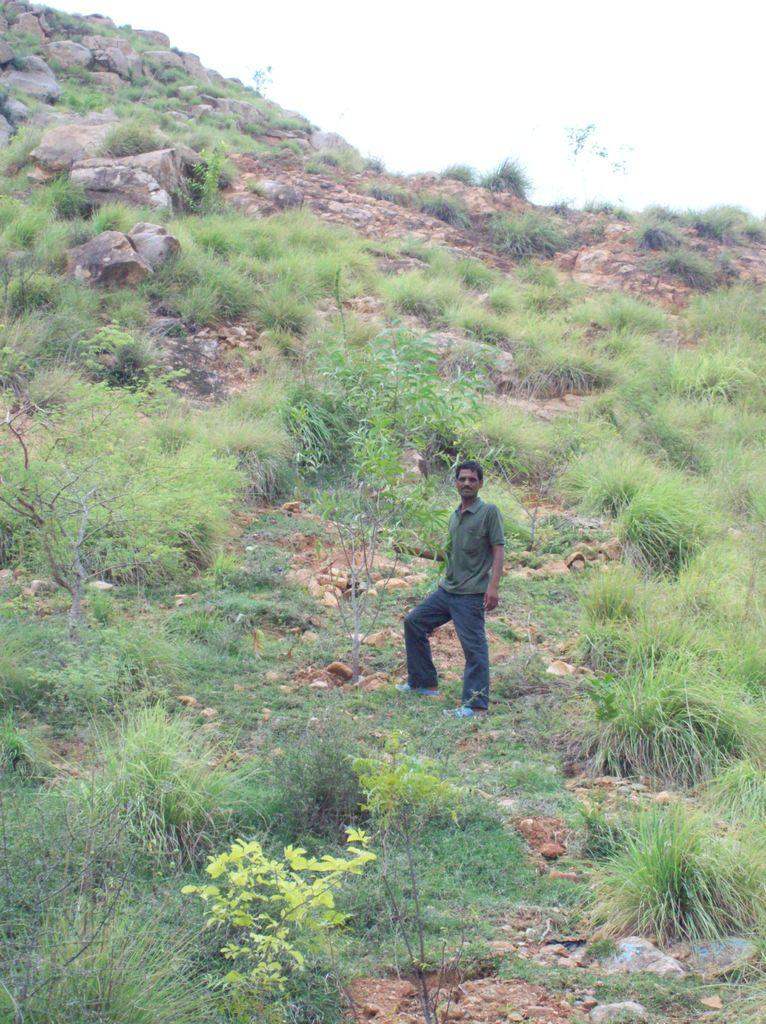What can be seen in the image? There is a person in the image. What is the person wearing? The person is wearing a gray T-shirt. Where is the person standing? The person is standing on a hill. What can be found on the hill? There are small plants and rocks on the hill. What is visible in the background of the image? The sky is visible in the background of the image. How many women are guiding the pot in the image? There is no pot or women present in the image. 